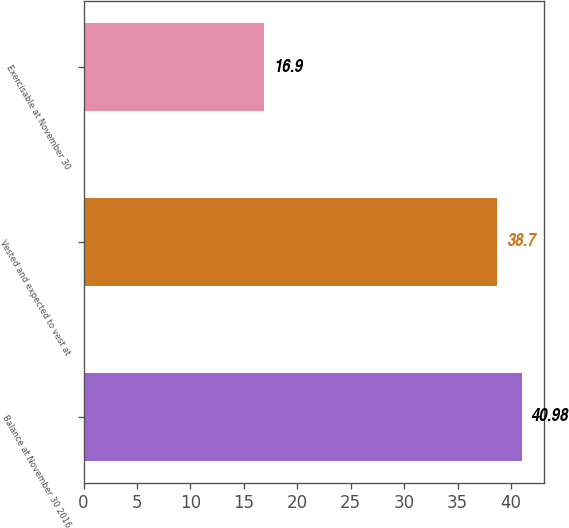Convert chart. <chart><loc_0><loc_0><loc_500><loc_500><bar_chart><fcel>Balance at November 30 2016<fcel>Vested and expected to vest at<fcel>Exercisable at November 30<nl><fcel>40.98<fcel>38.7<fcel>16.9<nl></chart> 